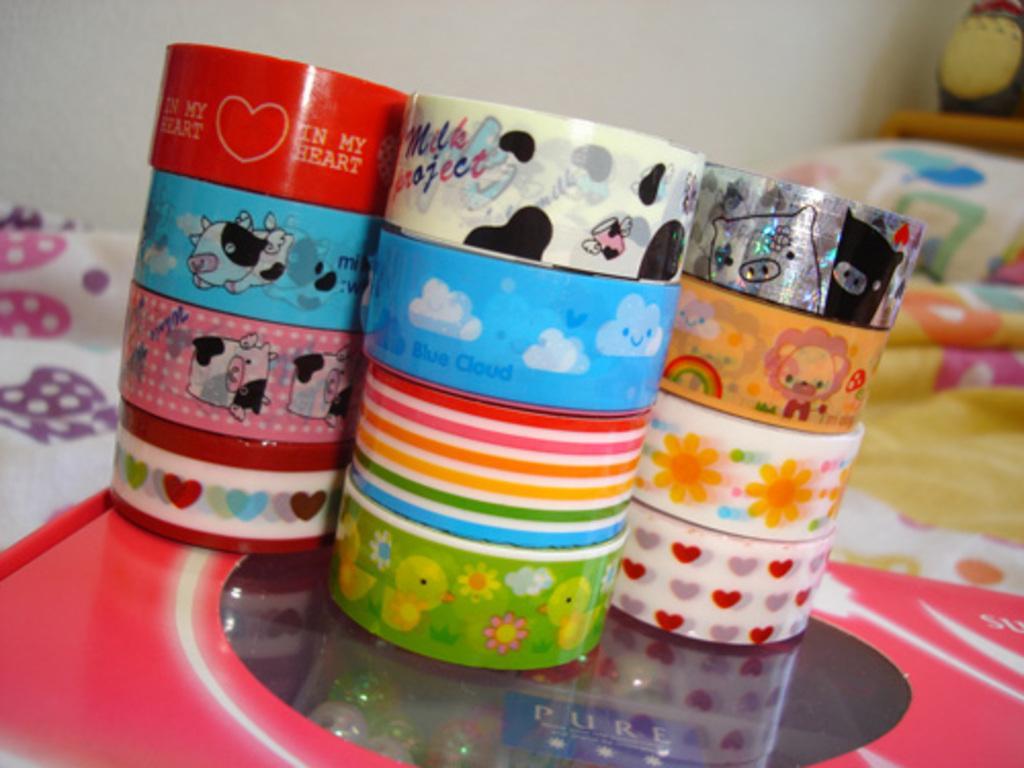In one or two sentences, can you explain what this image depicts? In this image we can see a bed. On the bed there is a box and some plasters. In the background there is a wall. 